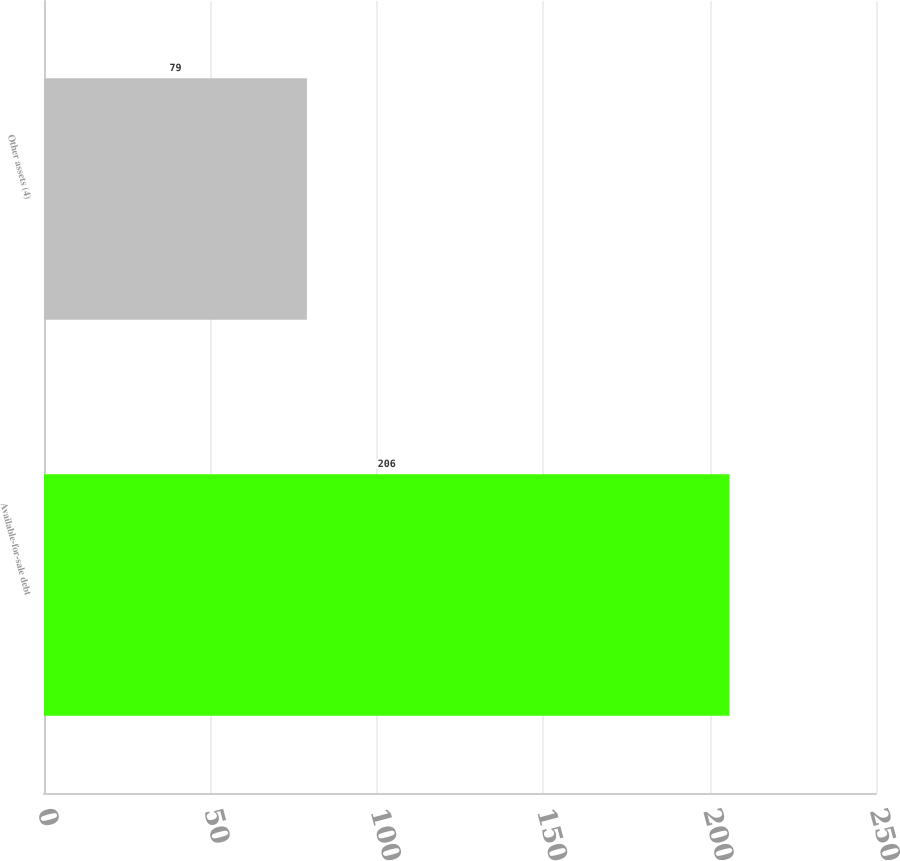Convert chart to OTSL. <chart><loc_0><loc_0><loc_500><loc_500><bar_chart><fcel>Available-for-sale debt<fcel>Other assets (4)<nl><fcel>206<fcel>79<nl></chart> 